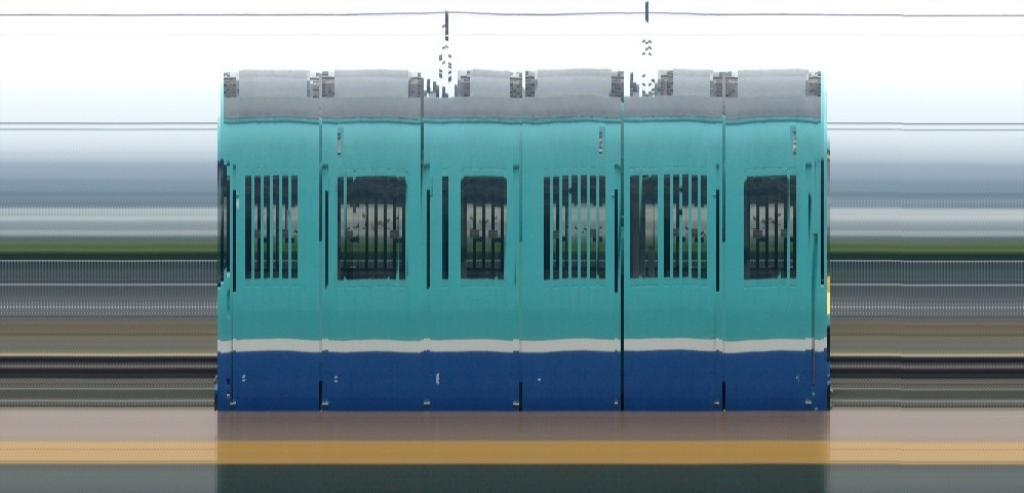What is located at the bottom of the image? There is a platform at the bottom of the image. What is the main subject in the middle of the image? There is a locomotive in the middle of the image. What is behind the locomotive in the image? There is fencing behind the locomotive. Is there a band playing music in the image? There is no band present in the image; it features a platform, a locomotive, and fencing. 